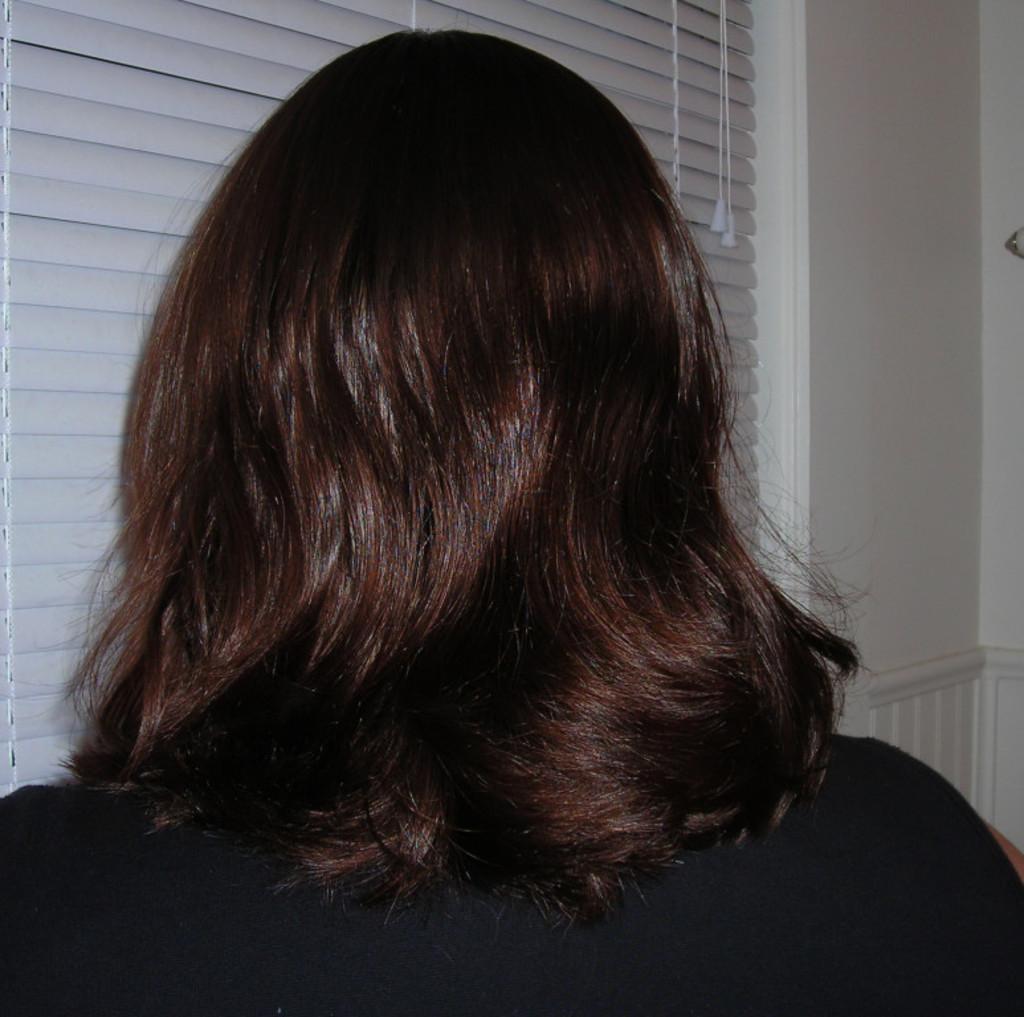How would you summarize this image in a sentence or two? In this image we can see a lady. In the background of the image there is a wall. There is a window. 